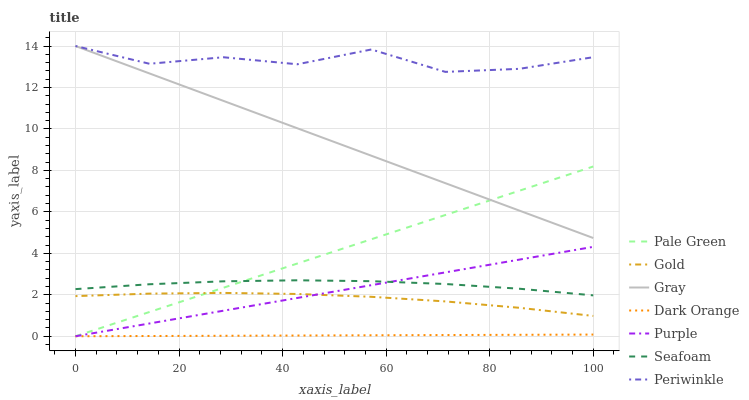Does Dark Orange have the minimum area under the curve?
Answer yes or no. Yes. Does Periwinkle have the maximum area under the curve?
Answer yes or no. Yes. Does Gold have the minimum area under the curve?
Answer yes or no. No. Does Gold have the maximum area under the curve?
Answer yes or no. No. Is Dark Orange the smoothest?
Answer yes or no. Yes. Is Periwinkle the roughest?
Answer yes or no. Yes. Is Gold the smoothest?
Answer yes or no. No. Is Gold the roughest?
Answer yes or no. No. Does Gold have the lowest value?
Answer yes or no. No. Does Gold have the highest value?
Answer yes or no. No. Is Gold less than Periwinkle?
Answer yes or no. Yes. Is Periwinkle greater than Seafoam?
Answer yes or no. Yes. Does Gold intersect Periwinkle?
Answer yes or no. No. 